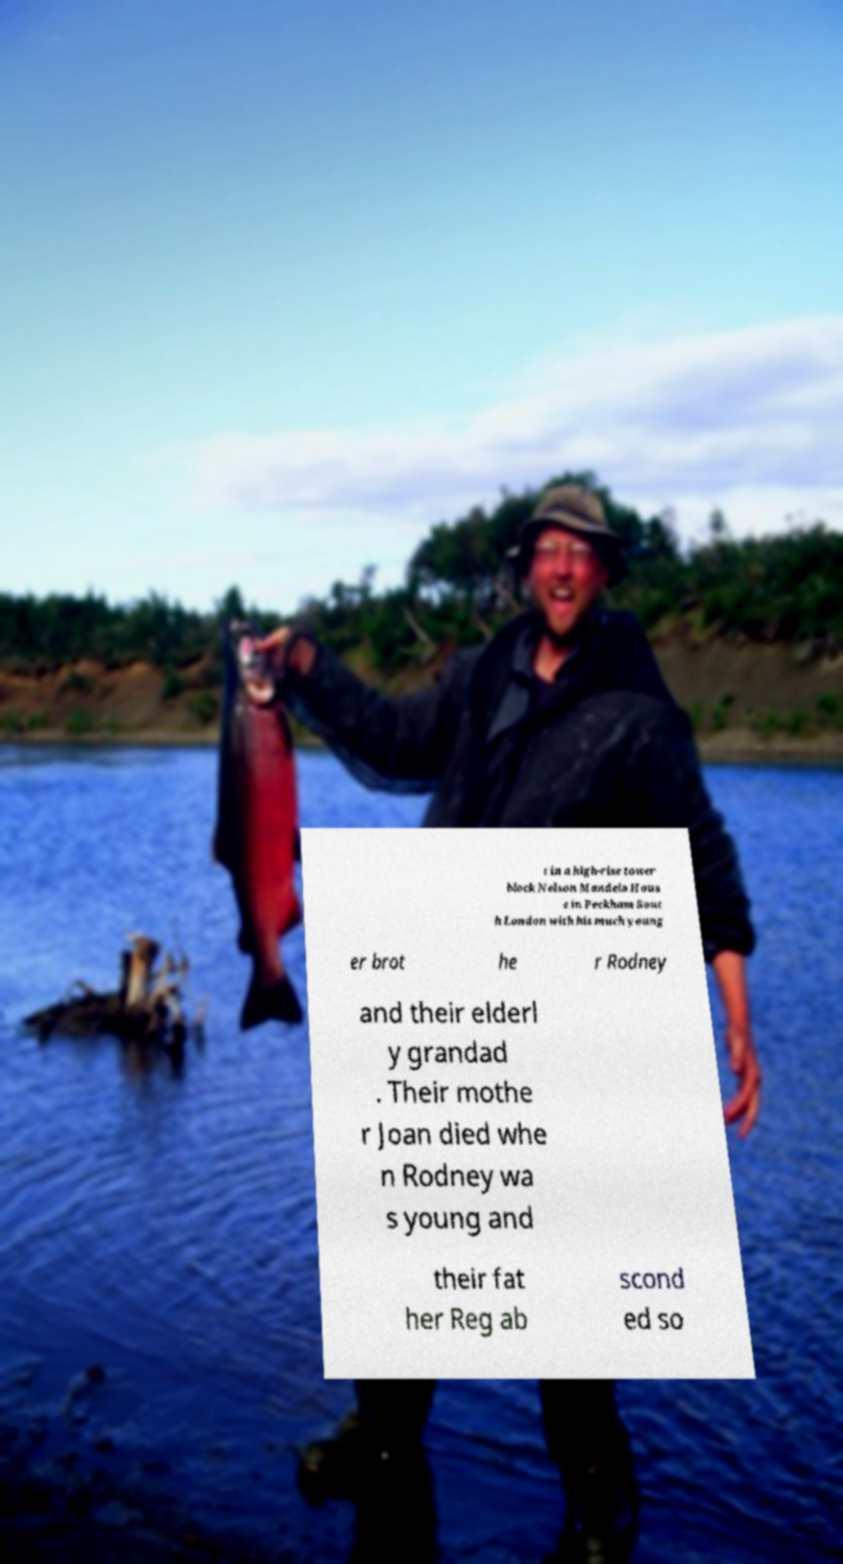Can you read and provide the text displayed in the image?This photo seems to have some interesting text. Can you extract and type it out for me? t in a high-rise tower block Nelson Mandela Hous e in Peckham Sout h London with his much young er brot he r Rodney and their elderl y grandad . Their mothe r Joan died whe n Rodney wa s young and their fat her Reg ab scond ed so 